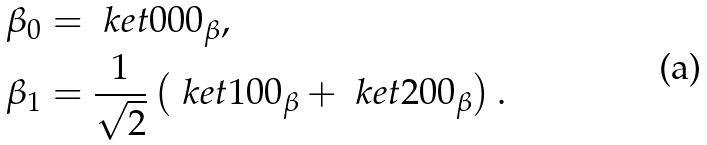<formula> <loc_0><loc_0><loc_500><loc_500>\beta _ { 0 } & = \ k e t { 0 0 0 } _ { \beta } , \\ \beta _ { 1 } & = \frac { 1 } { \sqrt { 2 } } \left ( \ k e t { 1 0 0 } _ { \beta } + \ k e t { 2 0 0 } _ { \beta } \right ) .</formula> 